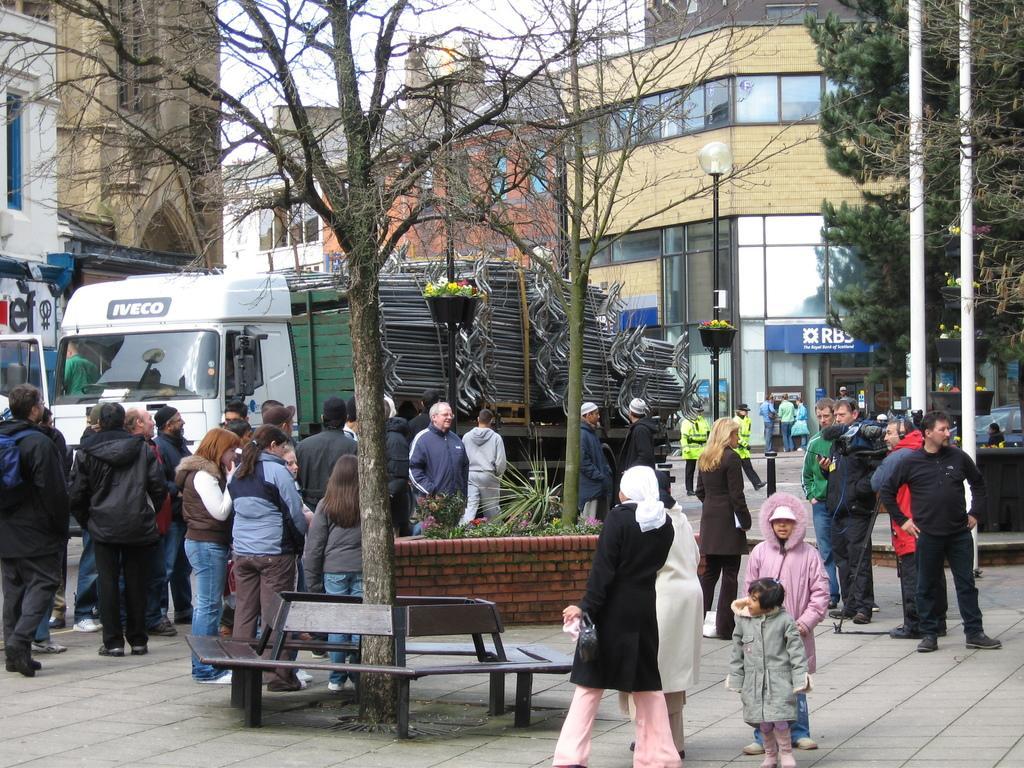In one or two sentences, can you explain what this image depicts? In this image we can see there are buildings, trees, poles, people, benches and vehicles. 